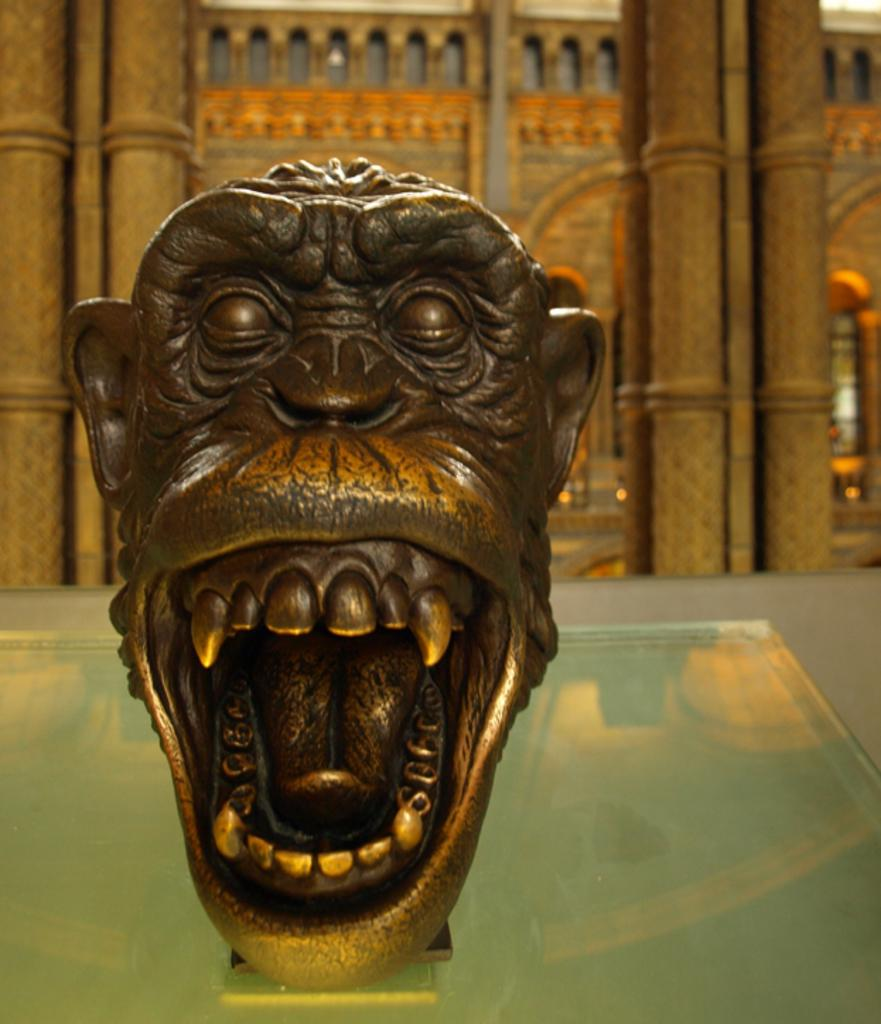What is the main subject of the image? There is a sculpture in the image. What is the sculpture resting on? The sculpture is on a glass platform. What can be seen in the background of the image? There are pillars and a wall in the background of the image. Is there a person sitting on a chair next to the sculpture in the image? There is no person or chair present in the image; it only features a sculpture on a glass platform with pillars and a wall in the background. 